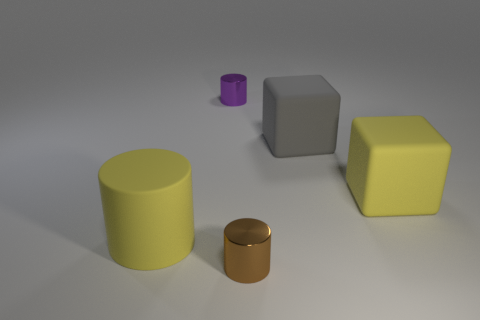Are there the same number of brown things on the right side of the brown shiny cylinder and metal things?
Keep it short and to the point. No. Do the cylinder that is behind the rubber cylinder and the cylinder right of the tiny purple metallic cylinder have the same size?
Provide a short and direct response. Yes. What number of other things are there of the same size as the brown object?
Give a very brief answer. 1. Is there a object that is to the right of the shiny object that is behind the large thing behind the yellow matte cube?
Give a very brief answer. Yes. Is there any other thing that has the same color as the big matte cylinder?
Your response must be concise. Yes. What size is the brown object to the right of the big yellow rubber cylinder?
Keep it short and to the point. Small. There is a metallic cylinder in front of the tiny object behind the rubber object to the left of the small brown metallic thing; what size is it?
Keep it short and to the point. Small. What color is the metal thing that is to the left of the tiny metallic thing that is in front of the yellow rubber block?
Make the answer very short. Purple. There is a large yellow thing that is the same shape as the small purple metallic object; what is it made of?
Your answer should be compact. Rubber. Is there any other thing that has the same material as the big yellow cylinder?
Offer a very short reply. Yes. 